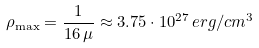<formula> <loc_0><loc_0><loc_500><loc_500>\rho _ { \max } = \frac { 1 } { 1 6 \, \mu } \approx 3 . 7 5 \cdot 1 0 ^ { 2 7 } \, e r g / c m ^ { 3 }</formula> 